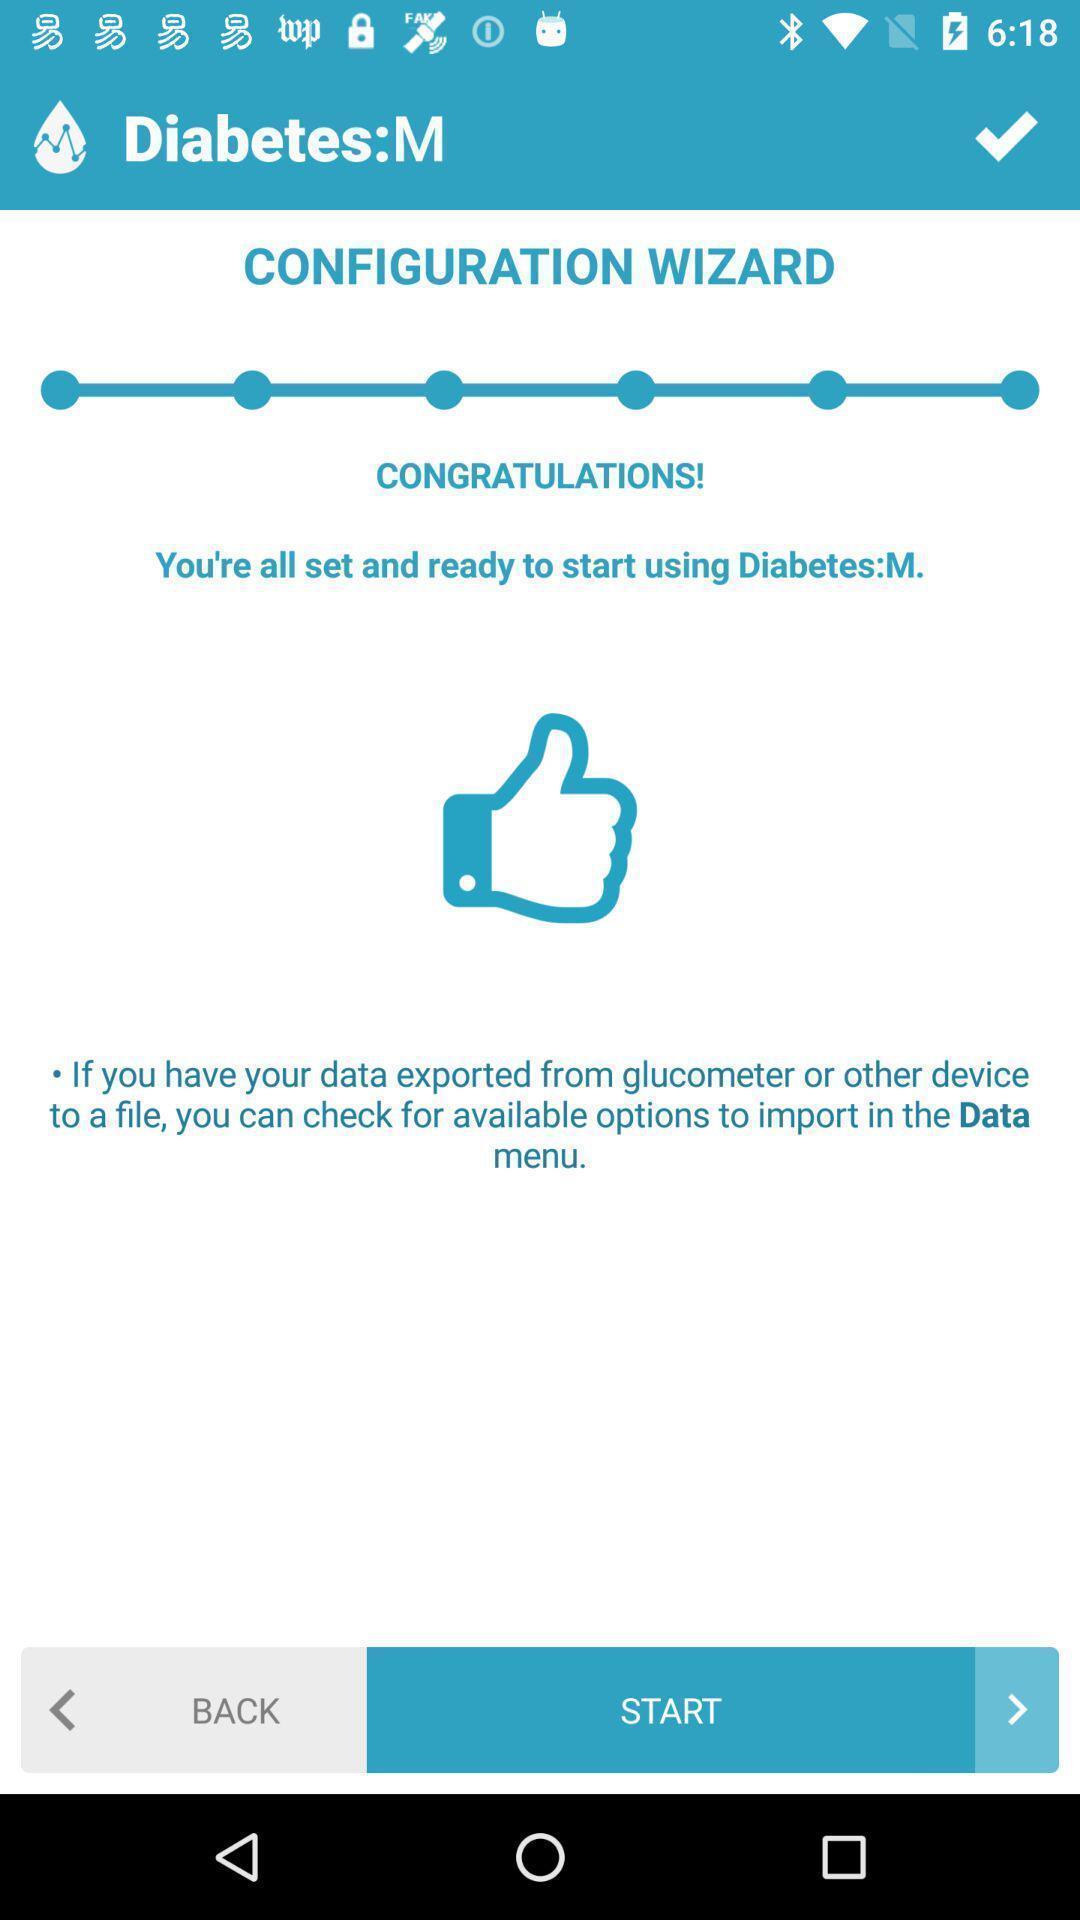Explain what's happening in this screen capture. Starting page. 